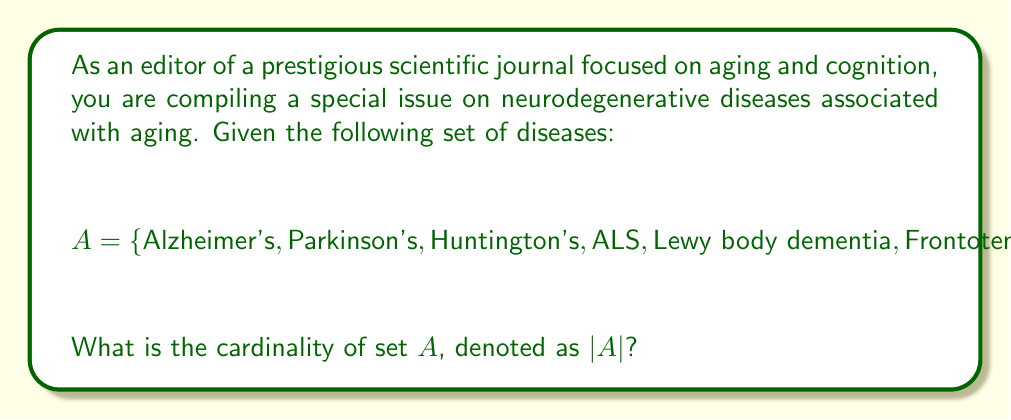Could you help me with this problem? To find the cardinality of set $A$, we need to count the number of distinct elements in the set. The cardinality of a finite set is simply the number of elements it contains.

Let's count the elements in set $A$:

1. Alzheimer's disease
2. Parkinson's disease
3. Huntington's disease
4. Amyotrophic Lateral Sclerosis (ALS)
5. Lewy body dementia
6. Frontotemporal dementia
7. Vascular dementia

Each disease is listed only once, and there are no repetitions. Therefore, the total number of distinct elements in set $A$ is 7.

In set theory notation, we express this as:

$$ |A| = 7 $$

where $|A|$ denotes the cardinality of set $A$.
Answer: $|A| = 7$ 